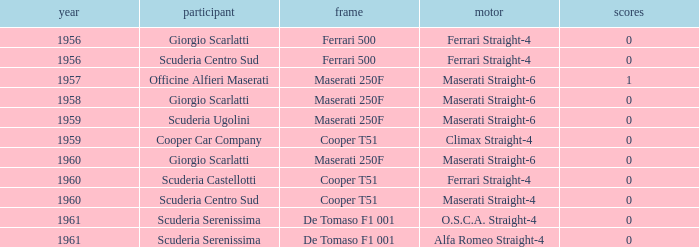How many points for the cooper car company after 1959? None. 